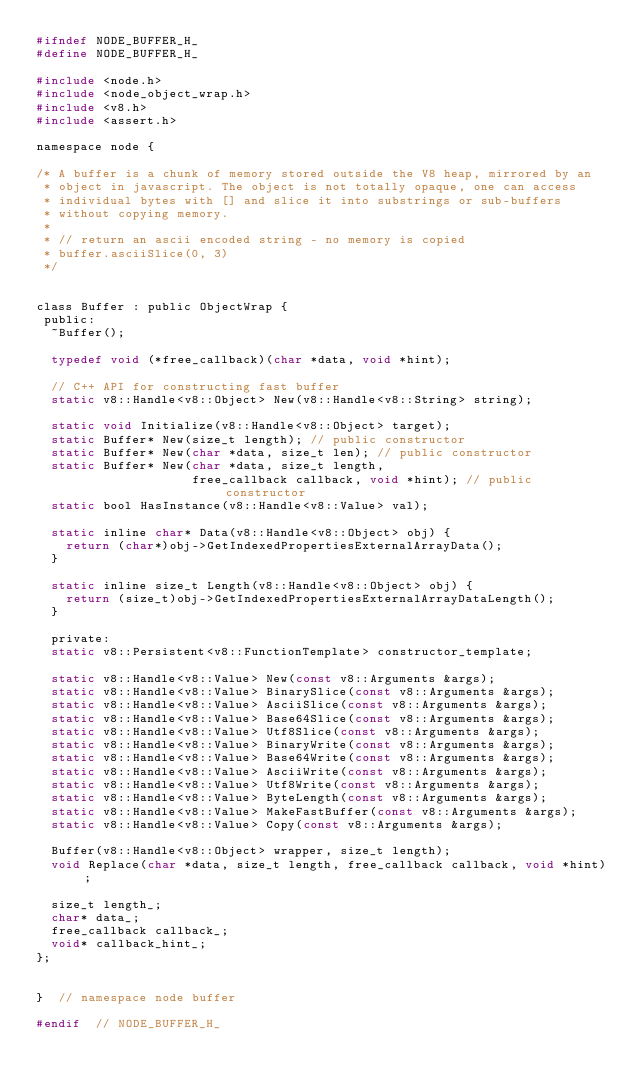<code> <loc_0><loc_0><loc_500><loc_500><_C_>#ifndef NODE_BUFFER_H_
#define NODE_BUFFER_H_

#include <node.h>
#include <node_object_wrap.h>
#include <v8.h>
#include <assert.h>

namespace node {

/* A buffer is a chunk of memory stored outside the V8 heap, mirrored by an
 * object in javascript. The object is not totally opaque, one can access
 * individual bytes with [] and slice it into substrings or sub-buffers
 * without copying memory.
 *
 * // return an ascii encoded string - no memory is copied
 * buffer.asciiSlice(0, 3)
 */


class Buffer : public ObjectWrap {
 public:
  ~Buffer();

  typedef void (*free_callback)(char *data, void *hint);

  // C++ API for constructing fast buffer
  static v8::Handle<v8::Object> New(v8::Handle<v8::String> string);

  static void Initialize(v8::Handle<v8::Object> target);
  static Buffer* New(size_t length); // public constructor
  static Buffer* New(char *data, size_t len); // public constructor
  static Buffer* New(char *data, size_t length,
                     free_callback callback, void *hint); // public constructor
  static bool HasInstance(v8::Handle<v8::Value> val);

  static inline char* Data(v8::Handle<v8::Object> obj) {
    return (char*)obj->GetIndexedPropertiesExternalArrayData();
  }

  static inline size_t Length(v8::Handle<v8::Object> obj) {
    return (size_t)obj->GetIndexedPropertiesExternalArrayDataLength();
  }

  private:
  static v8::Persistent<v8::FunctionTemplate> constructor_template;

  static v8::Handle<v8::Value> New(const v8::Arguments &args);
  static v8::Handle<v8::Value> BinarySlice(const v8::Arguments &args);
  static v8::Handle<v8::Value> AsciiSlice(const v8::Arguments &args);
  static v8::Handle<v8::Value> Base64Slice(const v8::Arguments &args);
  static v8::Handle<v8::Value> Utf8Slice(const v8::Arguments &args);
  static v8::Handle<v8::Value> BinaryWrite(const v8::Arguments &args);
  static v8::Handle<v8::Value> Base64Write(const v8::Arguments &args);
  static v8::Handle<v8::Value> AsciiWrite(const v8::Arguments &args);
  static v8::Handle<v8::Value> Utf8Write(const v8::Arguments &args);
  static v8::Handle<v8::Value> ByteLength(const v8::Arguments &args);
  static v8::Handle<v8::Value> MakeFastBuffer(const v8::Arguments &args);
  static v8::Handle<v8::Value> Copy(const v8::Arguments &args);

  Buffer(v8::Handle<v8::Object> wrapper, size_t length);
  void Replace(char *data, size_t length, free_callback callback, void *hint);

  size_t length_;
  char* data_;
  free_callback callback_;
  void* callback_hint_;
};


}  // namespace node buffer

#endif  // NODE_BUFFER_H_
</code> 